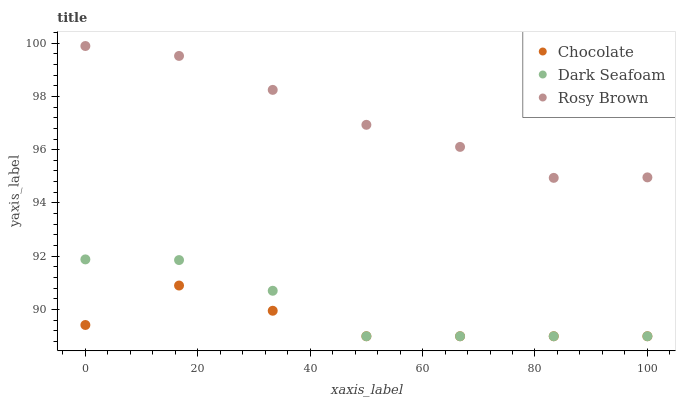Does Chocolate have the minimum area under the curve?
Answer yes or no. Yes. Does Rosy Brown have the maximum area under the curve?
Answer yes or no. Yes. Does Rosy Brown have the minimum area under the curve?
Answer yes or no. No. Does Chocolate have the maximum area under the curve?
Answer yes or no. No. Is Rosy Brown the smoothest?
Answer yes or no. Yes. Is Chocolate the roughest?
Answer yes or no. Yes. Is Chocolate the smoothest?
Answer yes or no. No. Is Rosy Brown the roughest?
Answer yes or no. No. Does Dark Seafoam have the lowest value?
Answer yes or no. Yes. Does Rosy Brown have the lowest value?
Answer yes or no. No. Does Rosy Brown have the highest value?
Answer yes or no. Yes. Does Chocolate have the highest value?
Answer yes or no. No. Is Dark Seafoam less than Rosy Brown?
Answer yes or no. Yes. Is Rosy Brown greater than Dark Seafoam?
Answer yes or no. Yes. Does Chocolate intersect Dark Seafoam?
Answer yes or no. Yes. Is Chocolate less than Dark Seafoam?
Answer yes or no. No. Is Chocolate greater than Dark Seafoam?
Answer yes or no. No. Does Dark Seafoam intersect Rosy Brown?
Answer yes or no. No. 